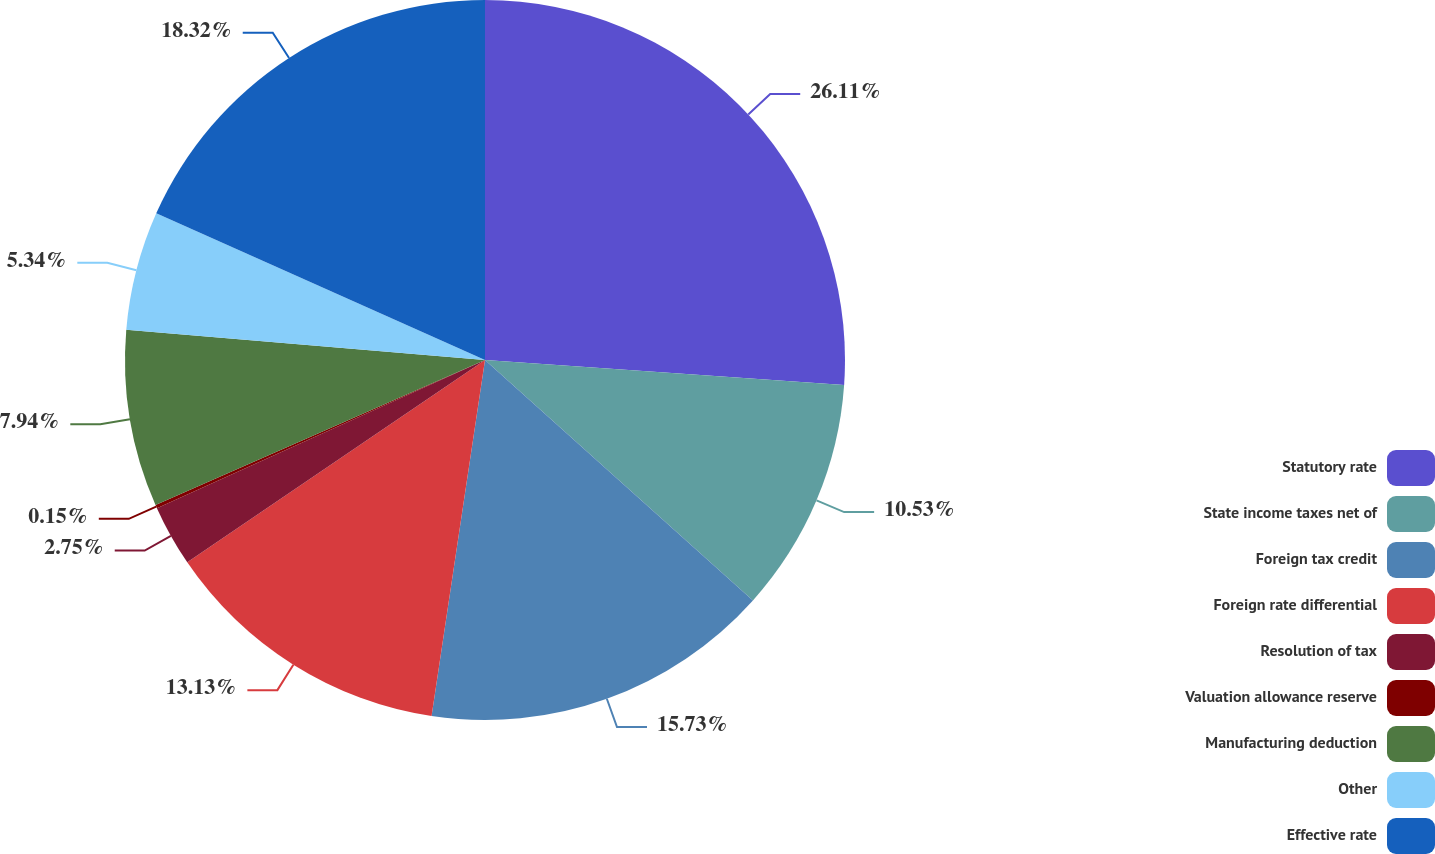Convert chart to OTSL. <chart><loc_0><loc_0><loc_500><loc_500><pie_chart><fcel>Statutory rate<fcel>State income taxes net of<fcel>Foreign tax credit<fcel>Foreign rate differential<fcel>Resolution of tax<fcel>Valuation allowance reserve<fcel>Manufacturing deduction<fcel>Other<fcel>Effective rate<nl><fcel>26.11%<fcel>10.53%<fcel>15.73%<fcel>13.13%<fcel>2.75%<fcel>0.15%<fcel>7.94%<fcel>5.34%<fcel>18.32%<nl></chart> 